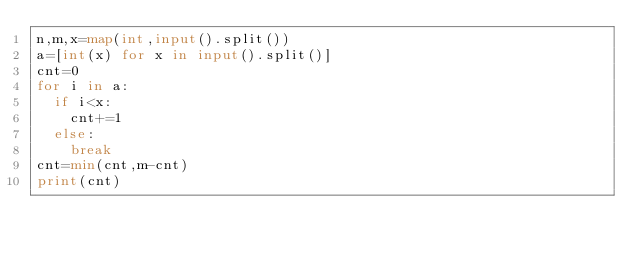Convert code to text. <code><loc_0><loc_0><loc_500><loc_500><_Python_>n,m,x=map(int,input().split())
a=[int(x) for x in input().split()]
cnt=0
for i in a:
  if i<x:
    cnt+=1
  else:
    break
cnt=min(cnt,m-cnt)
print(cnt)
</code> 